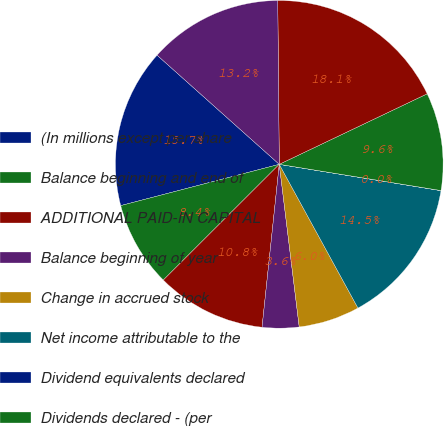<chart> <loc_0><loc_0><loc_500><loc_500><pie_chart><fcel>(In millions except per share<fcel>Balance beginning and end of<fcel>ADDITIONAL PAID-IN CAPITAL<fcel>Balance beginning of year<fcel>Change in accrued stock<fcel>Net income attributable to the<fcel>Dividend equivalents declared<fcel>Dividends declared - (per<fcel>Balance end of year<fcel>Other comprehensive (loss)<nl><fcel>15.66%<fcel>8.43%<fcel>10.84%<fcel>3.62%<fcel>6.03%<fcel>14.46%<fcel>0.01%<fcel>9.64%<fcel>18.07%<fcel>13.25%<nl></chart> 